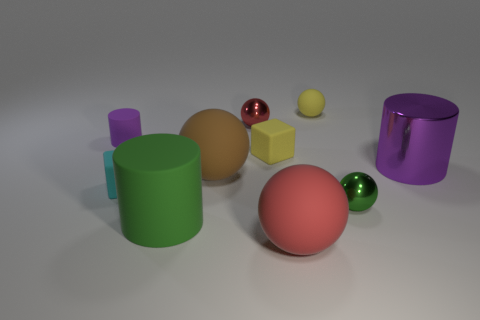Is the shape of the brown rubber thing the same as the green metal thing?
Offer a very short reply. Yes. What number of things are matte cylinders on the left side of the green rubber thing or tiny balls?
Keep it short and to the point. 4. The green thing that is the same material as the large purple cylinder is what size?
Offer a terse response. Small. How many tiny metal objects are the same color as the large matte cylinder?
Provide a succinct answer. 1. How many large objects are either purple matte things or rubber cylinders?
Your response must be concise. 1. There is a matte object that is the same color as the metallic cylinder; what size is it?
Make the answer very short. Small. Are there any large cylinders made of the same material as the green ball?
Your response must be concise. Yes. What is the purple object in front of the small yellow block made of?
Your answer should be compact. Metal. There is a large sphere that is in front of the green ball; does it have the same color as the tiny metallic thing behind the big brown sphere?
Make the answer very short. Yes. What color is the metallic cylinder that is the same size as the red rubber ball?
Make the answer very short. Purple. 